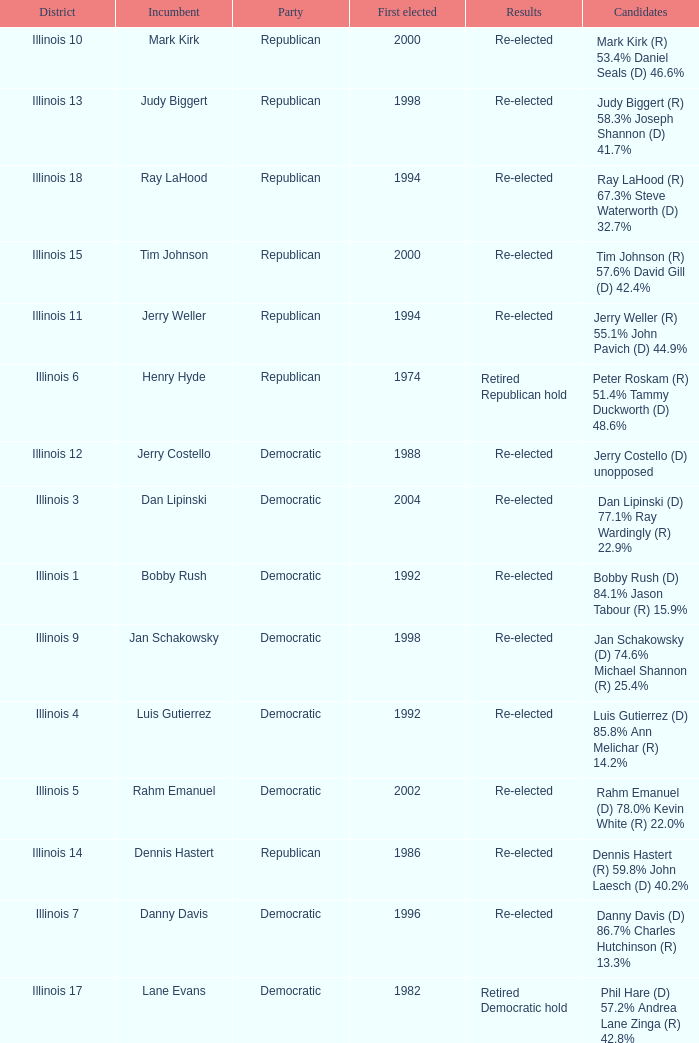Who were the candidates when the first elected was a republican in 1998?  Judy Biggert (R) 58.3% Joseph Shannon (D) 41.7%. 